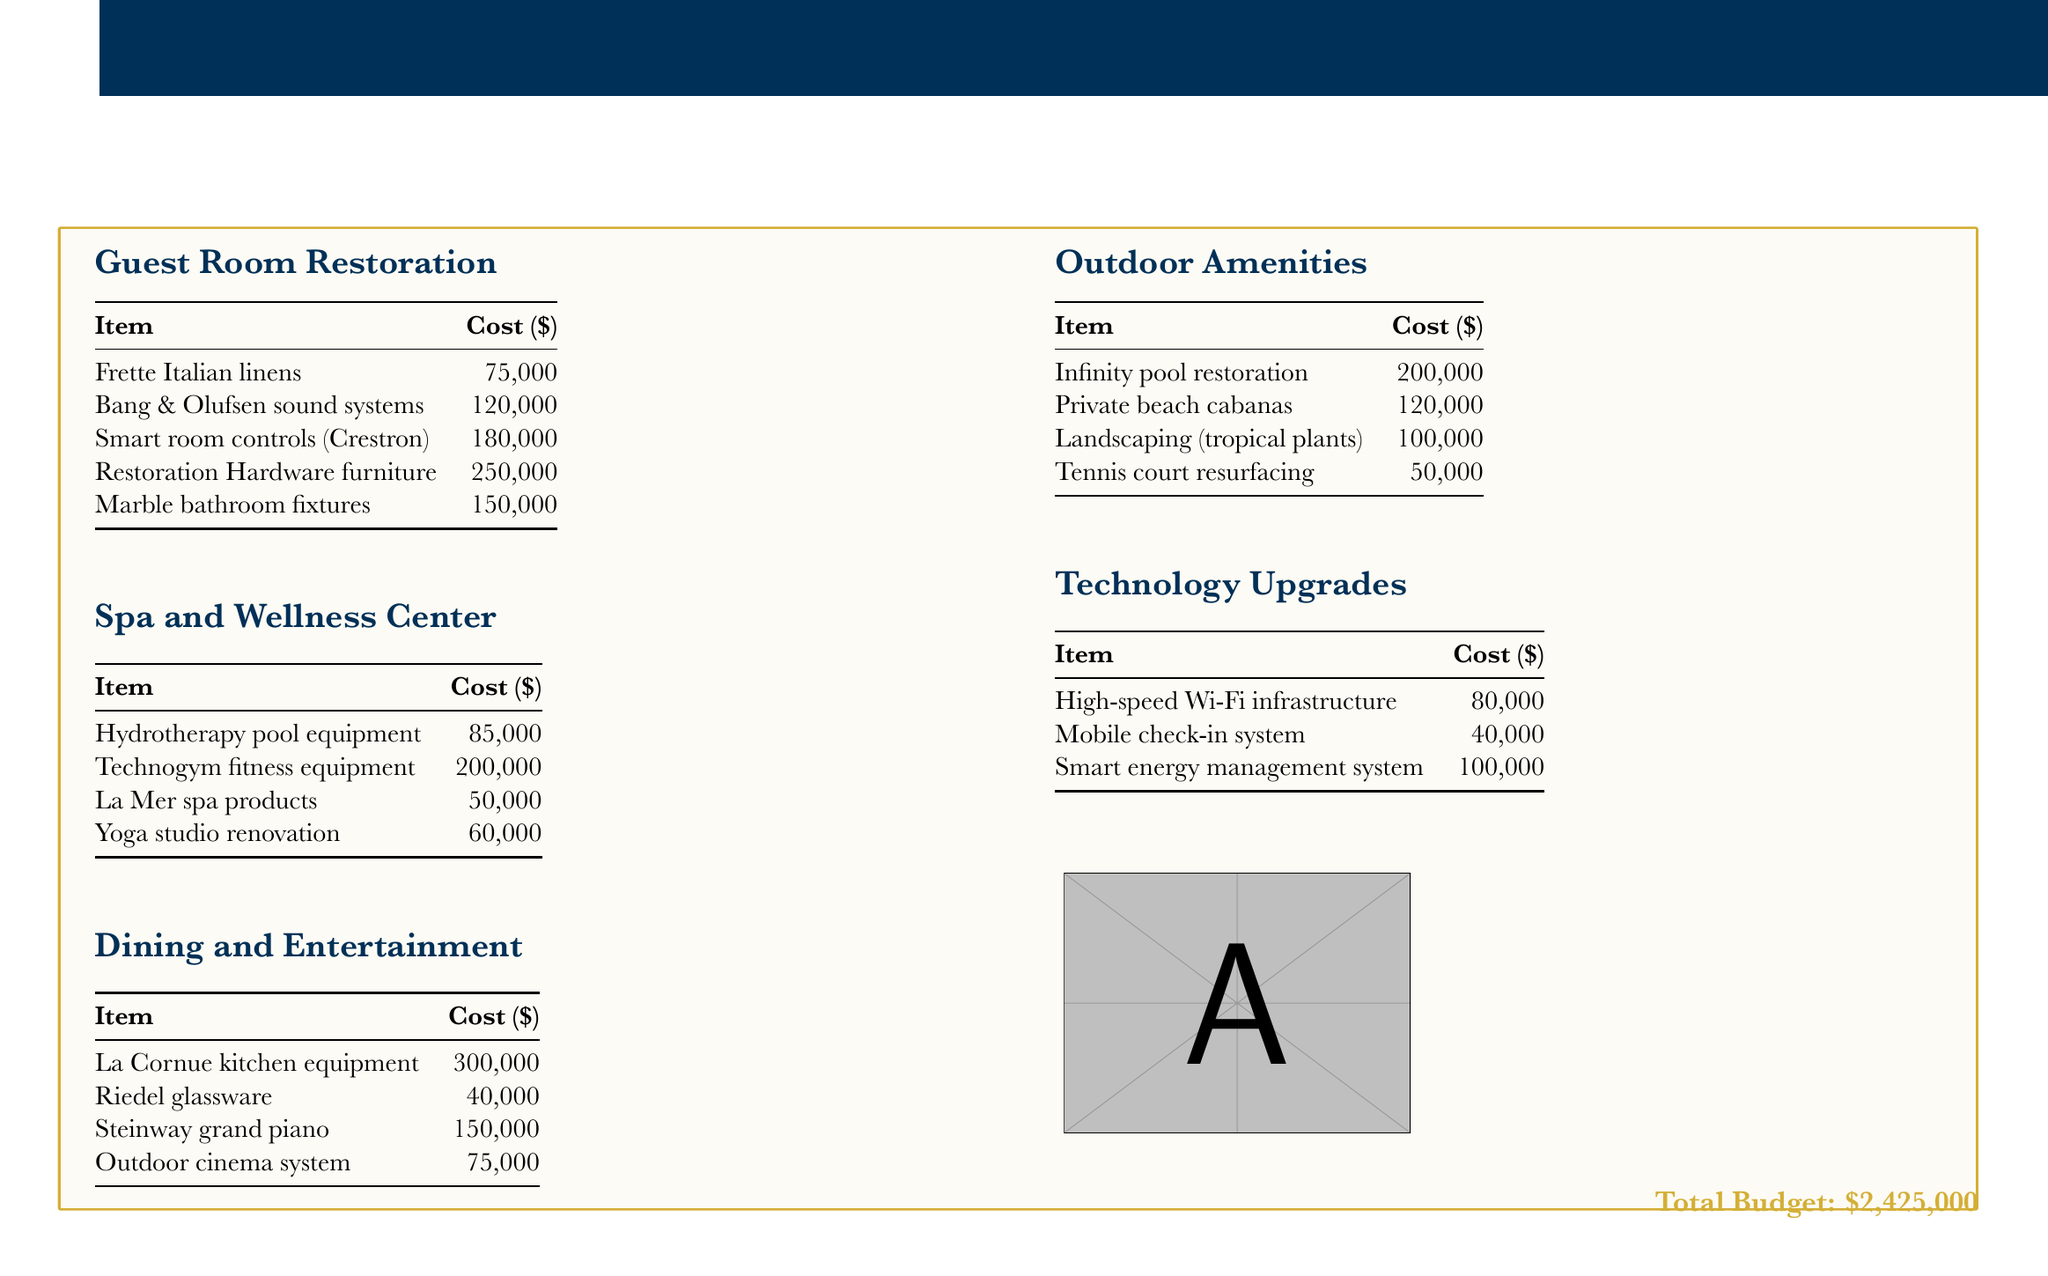What is the total budget? The total budget is explicitly mentioned at the end of the document.
Answer: $2,425,000 How much is allocated for Frette Italian linens? This specific cost is listed under the Guest Room Restoration section.
Answer: $75,000 What type of kitchen equipment is included in the Dining and Entertainment section? This is specified in the dining section, which lists high-end kitchen equipment.
Answer: La Cornue kitchen equipment What is the cost of the Infinity pool restoration? The cost of the Infinity pool restoration is mentioned under the Outdoor Amenities section.
Answer: $200,000 Which sound system is included in the Guest Room Restoration? This information can be found in the first section of the document under guest room items.
Answer: Bang & Olufsen sound systems How much is planned for the Yoga studio renovation? This cost is detailed in the Spa and Wellness Center section.
Answer: $60,000 Which item has the highest cost in the Outdoor Amenities section? This requires evaluating the costs listed in the Outdoor Amenities section to determine the highest.
Answer: Infinity pool restoration What is the cost for the Smart energy management system? This piece of information is provided in the Technology Upgrades section.
Answer: $100,000 What luxury feature is associated with Smart room controls? This item is noted in the Guest Room Restoration section as a luxury upgrade.
Answer: Crestron 